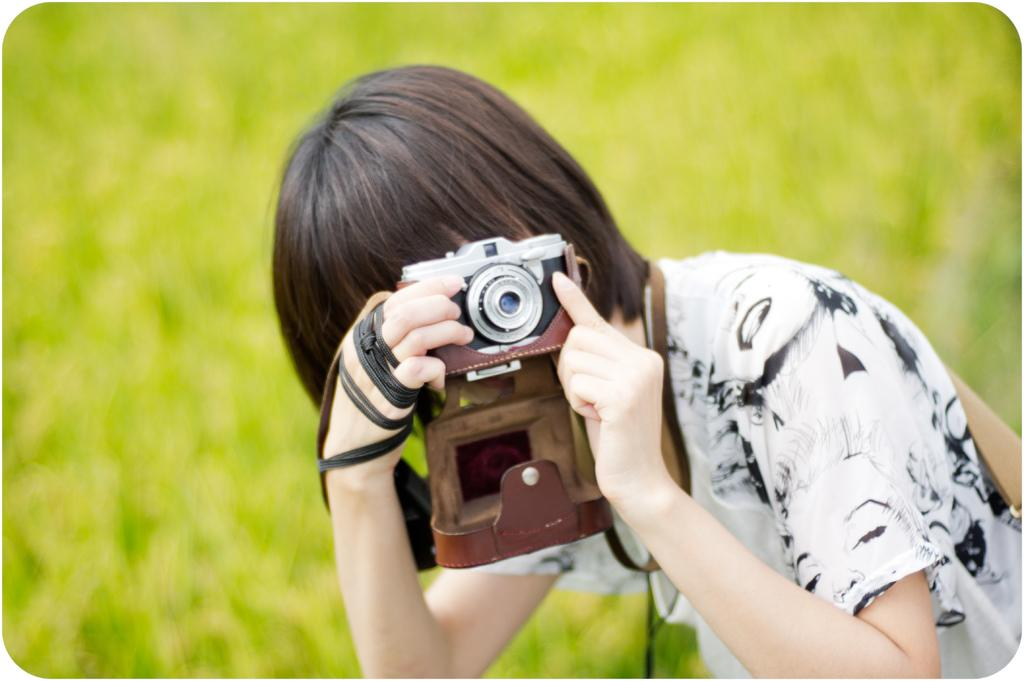What can be seen in the background of the image? The background of the image is green and blurry. Can you describe the person in the image? There is a person in the image, and they are holding a camera in their hands. What is the person wearing? The person is wearing a black and white t-shirt. What type of bridge can be seen in the image? There is no bridge present in the image. Is the person drinking eggnog in the image? There is no eggnog present in the image. 